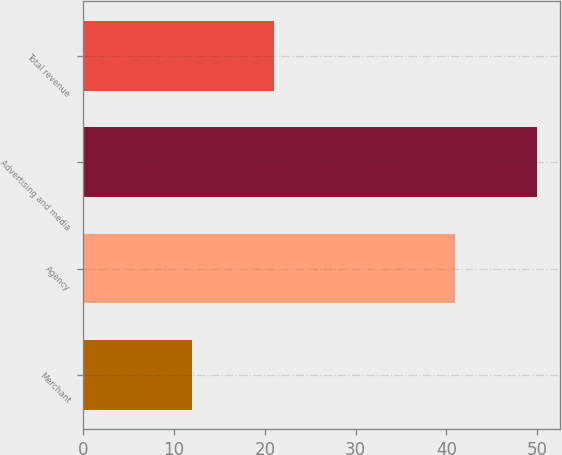Convert chart. <chart><loc_0><loc_0><loc_500><loc_500><bar_chart><fcel>Merchant<fcel>Agency<fcel>Advertising and media<fcel>Total revenue<nl><fcel>12<fcel>41<fcel>50<fcel>21<nl></chart> 